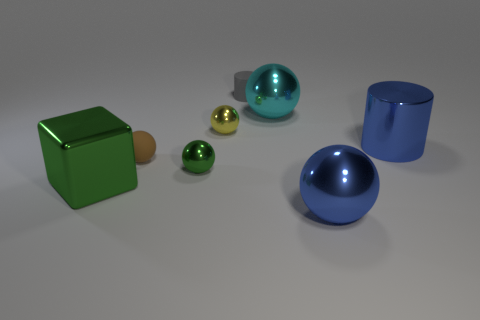Subtract all big blue shiny balls. How many balls are left? 4 Add 1 tiny metal balls. How many objects exist? 9 Subtract 1 cylinders. How many cylinders are left? 1 Subtract all yellow balls. How many balls are left? 4 Subtract 0 gray balls. How many objects are left? 8 Subtract all cylinders. How many objects are left? 6 Subtract all brown cubes. Subtract all brown cylinders. How many cubes are left? 1 Subtract all small brown rubber cylinders. Subtract all small gray rubber cylinders. How many objects are left? 7 Add 7 green shiny spheres. How many green shiny spheres are left? 8 Add 8 tiny red shiny balls. How many tiny red shiny balls exist? 8 